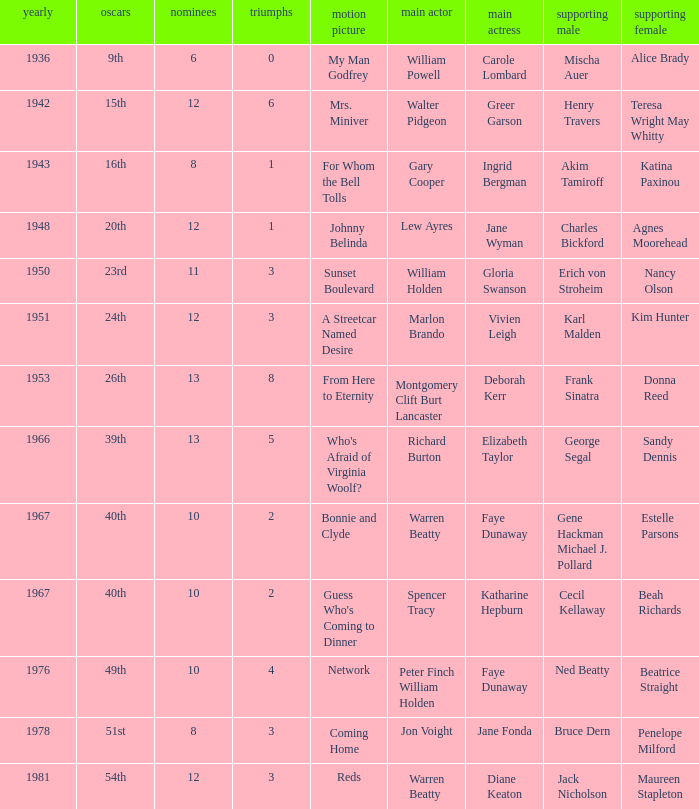Which film had Charles Bickford as supporting actor? Johnny Belinda. 